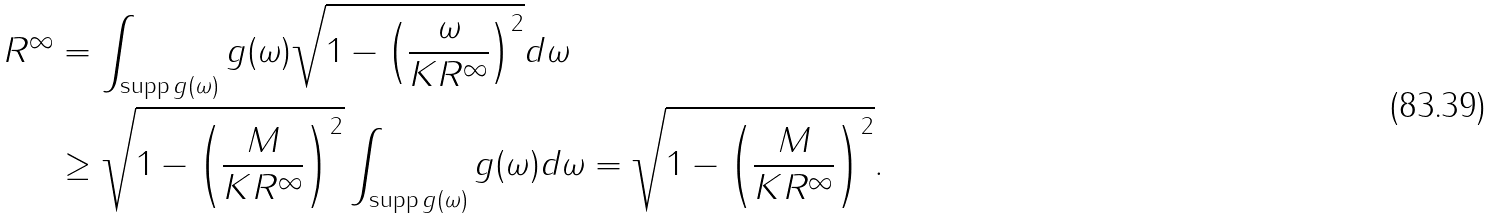Convert formula to latex. <formula><loc_0><loc_0><loc_500><loc_500>R ^ { \infty } & = \int _ { \text {supp} \, g ( \omega ) } g ( \omega ) \sqrt { 1 - \left ( \frac { \omega } { K R ^ { \infty } } \right ) ^ { 2 } } d \omega \\ & \geq \sqrt { 1 - \left ( \frac { M } { K R ^ { \infty } } \right ) ^ { 2 } } \int _ { \text {supp} \, g ( \omega ) } g ( \omega ) d \omega = \sqrt { 1 - \left ( \frac { M } { K R ^ { \infty } } \right ) ^ { 2 } } .</formula> 